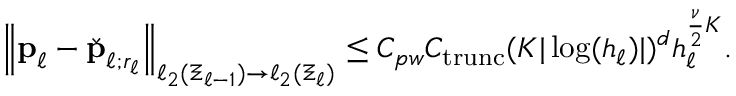Convert formula to latex. <formula><loc_0><loc_0><loc_500><loc_500>\begin{array} { r } { \left \| p _ { \ell } - \check { p } _ { \ell ; r _ { \ell } } \right \| _ { \ell _ { 2 } ( \Xi _ { \ell - 1 } ) \to \ell _ { 2 } ( \Xi _ { \ell } ) } \leq C _ { p w } C _ { t r u n c } ( K | \log ( h _ { \ell } ) | ) ^ { d } h _ { \ell } ^ { \frac { \nu } { 2 } K } . } \end{array}</formula> 